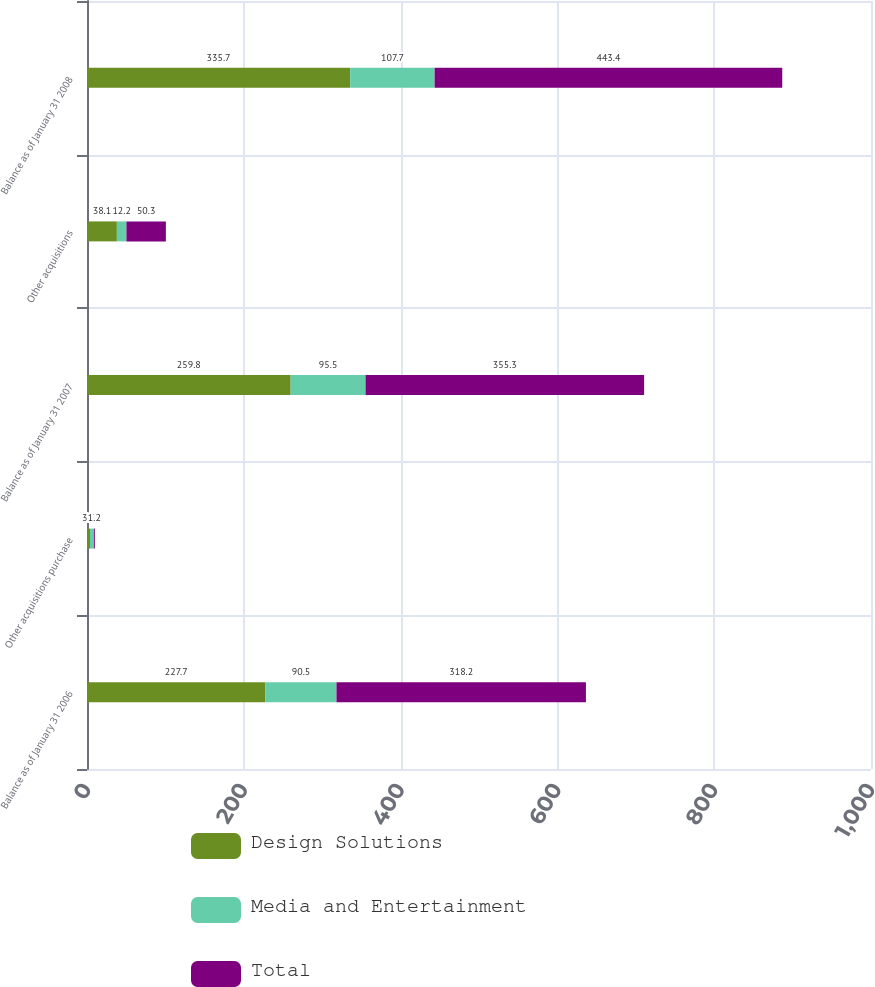Convert chart. <chart><loc_0><loc_0><loc_500><loc_500><stacked_bar_chart><ecel><fcel>Balance as of January 31 2006<fcel>Other acquisitions purchase<fcel>Balance as of January 31 2007<fcel>Other acquisitions<fcel>Balance as of January 31 2008<nl><fcel>Design Solutions<fcel>227.7<fcel>3.8<fcel>259.8<fcel>38.1<fcel>335.7<nl><fcel>Media and Entertainment<fcel>90.5<fcel>5<fcel>95.5<fcel>12.2<fcel>107.7<nl><fcel>Total<fcel>318.2<fcel>1.2<fcel>355.3<fcel>50.3<fcel>443.4<nl></chart> 